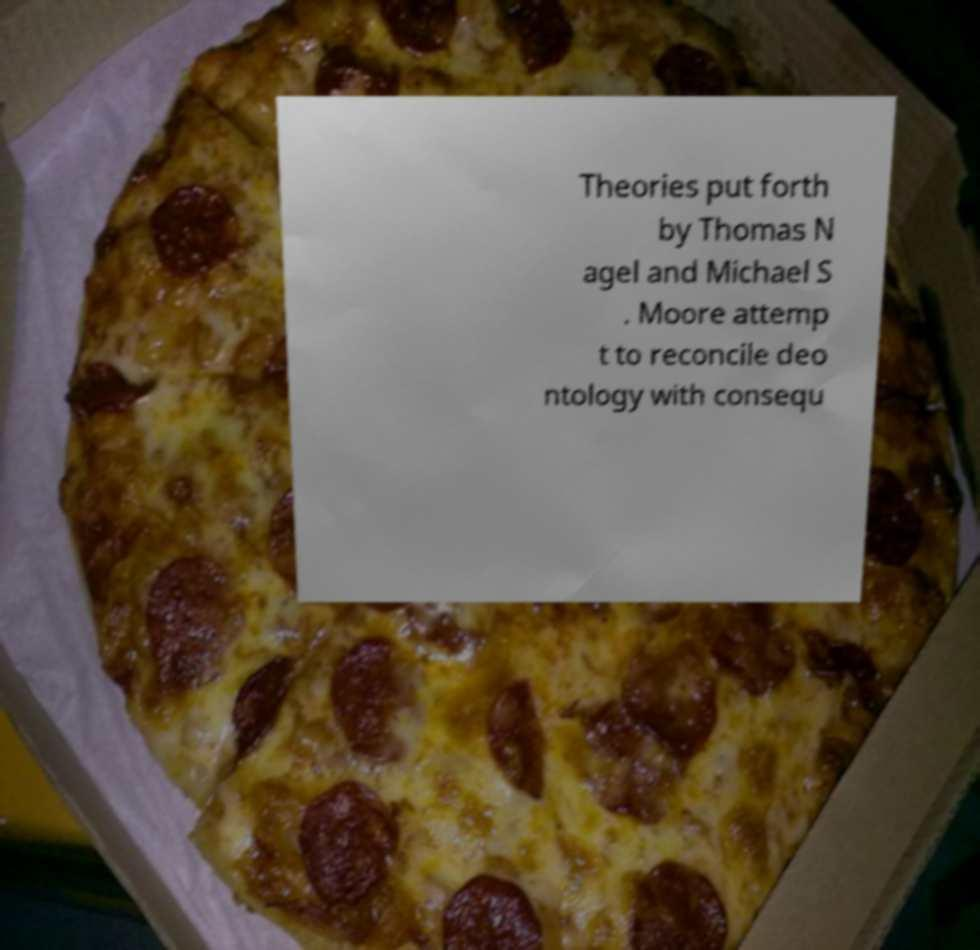What messages or text are displayed in this image? I need them in a readable, typed format. Theories put forth by Thomas N agel and Michael S . Moore attemp t to reconcile deo ntology with consequ 